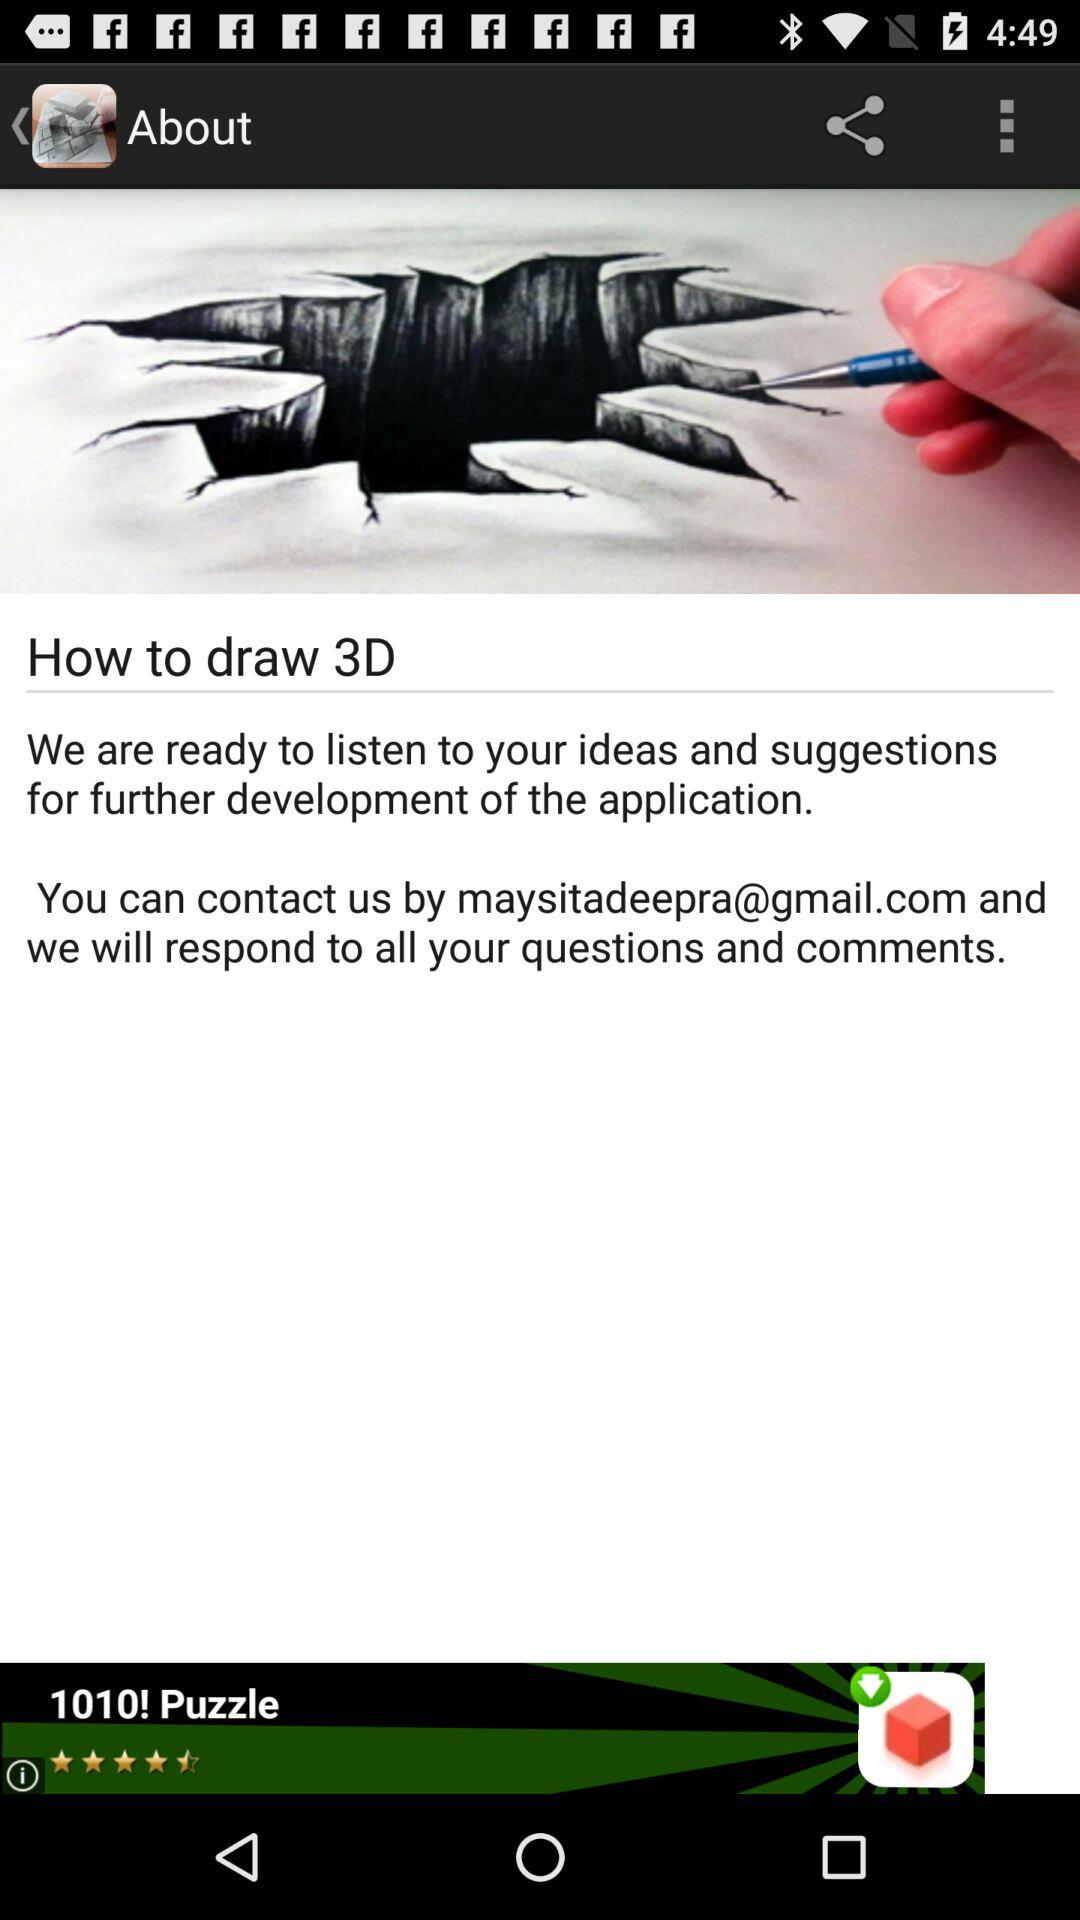What is the mentioned email address? The mentioned email address is maysitadeepra@gmail.com. 